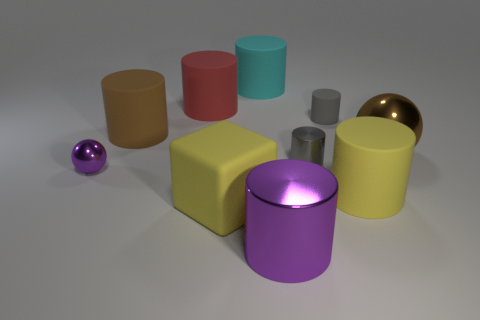What is the material of the large cylinder that is the same color as the large matte block?
Your response must be concise. Rubber. Is the red cylinder made of the same material as the large cyan cylinder?
Give a very brief answer. Yes. What number of cyan objects have the same material as the big brown ball?
Give a very brief answer. 0. How many objects are things that are in front of the large metallic sphere or large matte things that are behind the small gray metallic object?
Provide a succinct answer. 8. Are there more cyan rubber cylinders left of the big red thing than small purple shiny things to the right of the cyan rubber thing?
Your answer should be compact. No. There is a sphere on the left side of the brown rubber object; what color is it?
Offer a terse response. Purple. Is there another big object that has the same shape as the large red rubber object?
Ensure brevity in your answer.  Yes. How many blue things are either metallic blocks or matte cylinders?
Ensure brevity in your answer.  0. Is there a rubber cylinder of the same size as the red matte thing?
Your answer should be very brief. Yes. How many brown shiny balls are there?
Your answer should be compact. 1. 